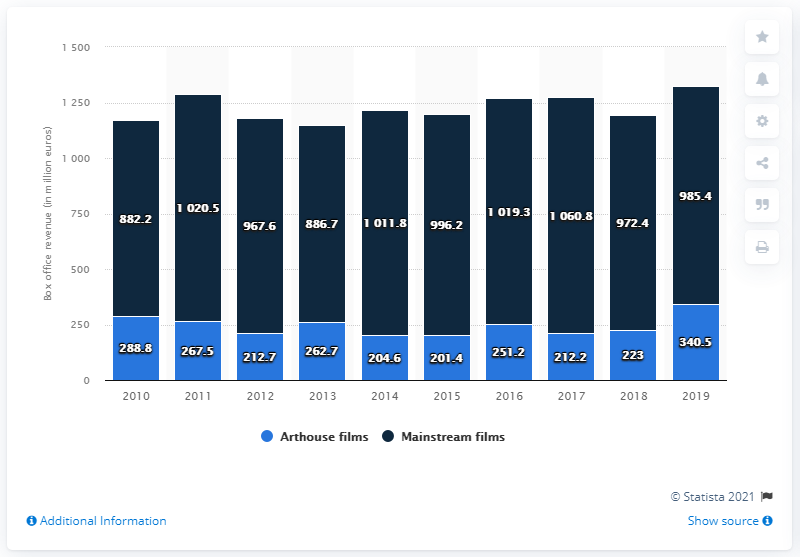Draw attention to some important aspects in this diagram. In 2019, the revenue generated from the sale of mainstream films was approximately 985.4 million dollars. 